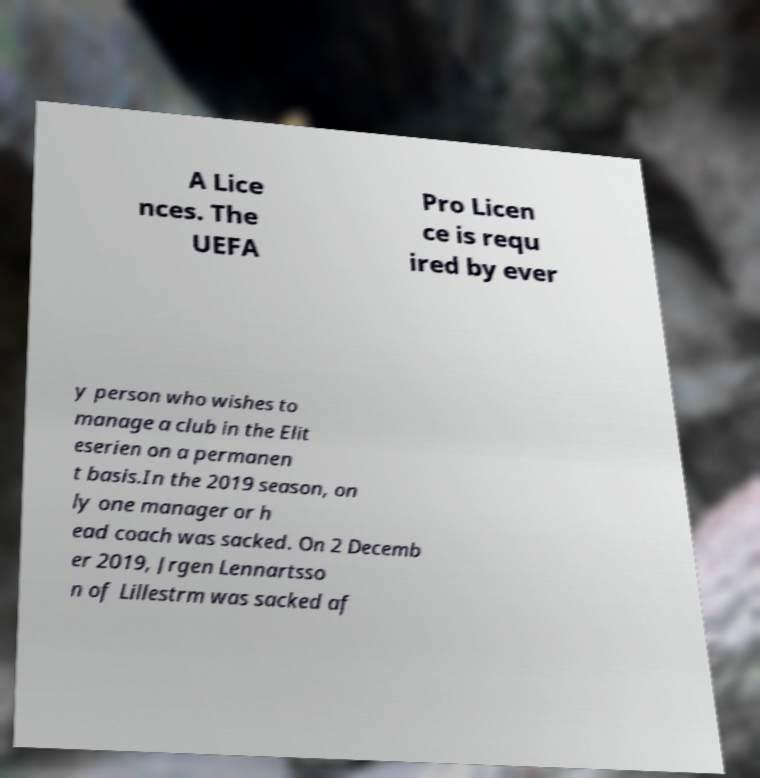Please read and relay the text visible in this image. What does it say? A Lice nces. The UEFA Pro Licen ce is requ ired by ever y person who wishes to manage a club in the Elit eserien on a permanen t basis.In the 2019 season, on ly one manager or h ead coach was sacked. On 2 Decemb er 2019, Jrgen Lennartsso n of Lillestrm was sacked af 